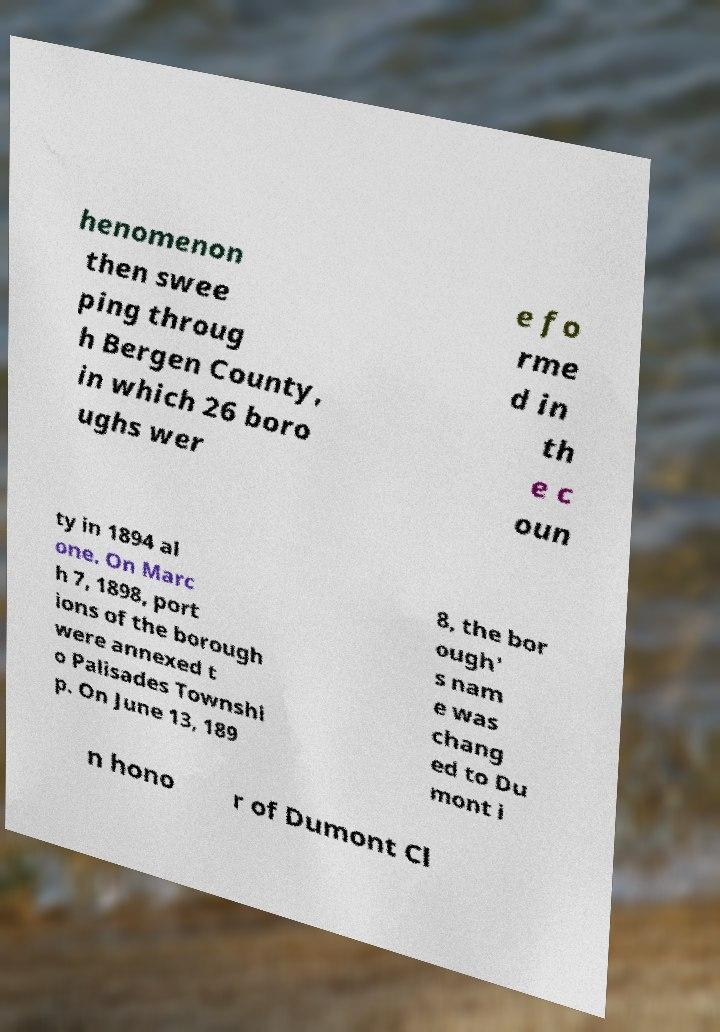What messages or text are displayed in this image? I need them in a readable, typed format. henomenon then swee ping throug h Bergen County, in which 26 boro ughs wer e fo rme d in th e c oun ty in 1894 al one. On Marc h 7, 1898, port ions of the borough were annexed t o Palisades Townshi p. On June 13, 189 8, the bor ough' s nam e was chang ed to Du mont i n hono r of Dumont Cl 